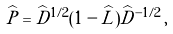Convert formula to latex. <formula><loc_0><loc_0><loc_500><loc_500>\widehat { P } = \widehat { D } ^ { 1 / 2 } ( 1 - \widehat { L } ) \widehat { D } ^ { - 1 / 2 } \, ,</formula> 